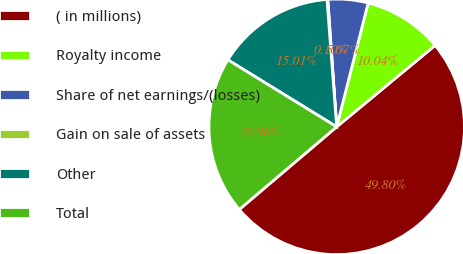Convert chart. <chart><loc_0><loc_0><loc_500><loc_500><pie_chart><fcel>( in millions)<fcel>Royalty income<fcel>Share of net earnings/(losses)<fcel>Gain on sale of assets<fcel>Other<fcel>Total<nl><fcel>49.8%<fcel>10.04%<fcel>5.07%<fcel>0.1%<fcel>15.01%<fcel>19.98%<nl></chart> 